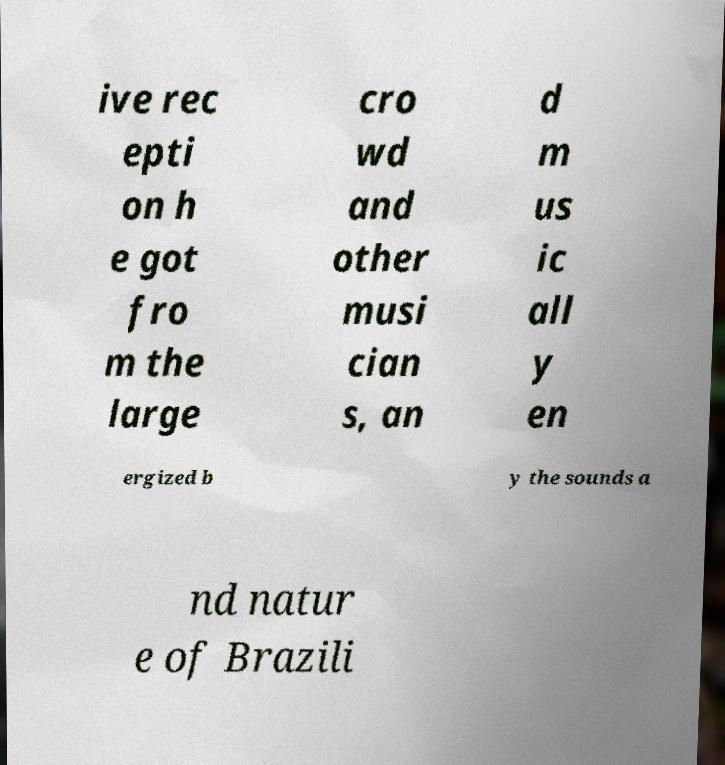Can you accurately transcribe the text from the provided image for me? ive rec epti on h e got fro m the large cro wd and other musi cian s, an d m us ic all y en ergized b y the sounds a nd natur e of Brazili 